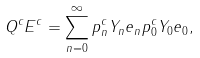<formula> <loc_0><loc_0><loc_500><loc_500>Q ^ { c } E ^ { c } = \sum _ { n = 0 } ^ { \infty } p ^ { c } _ { n } Y _ { n } e _ { n } p ^ { c } _ { 0 } Y _ { 0 } e _ { 0 } ,</formula> 